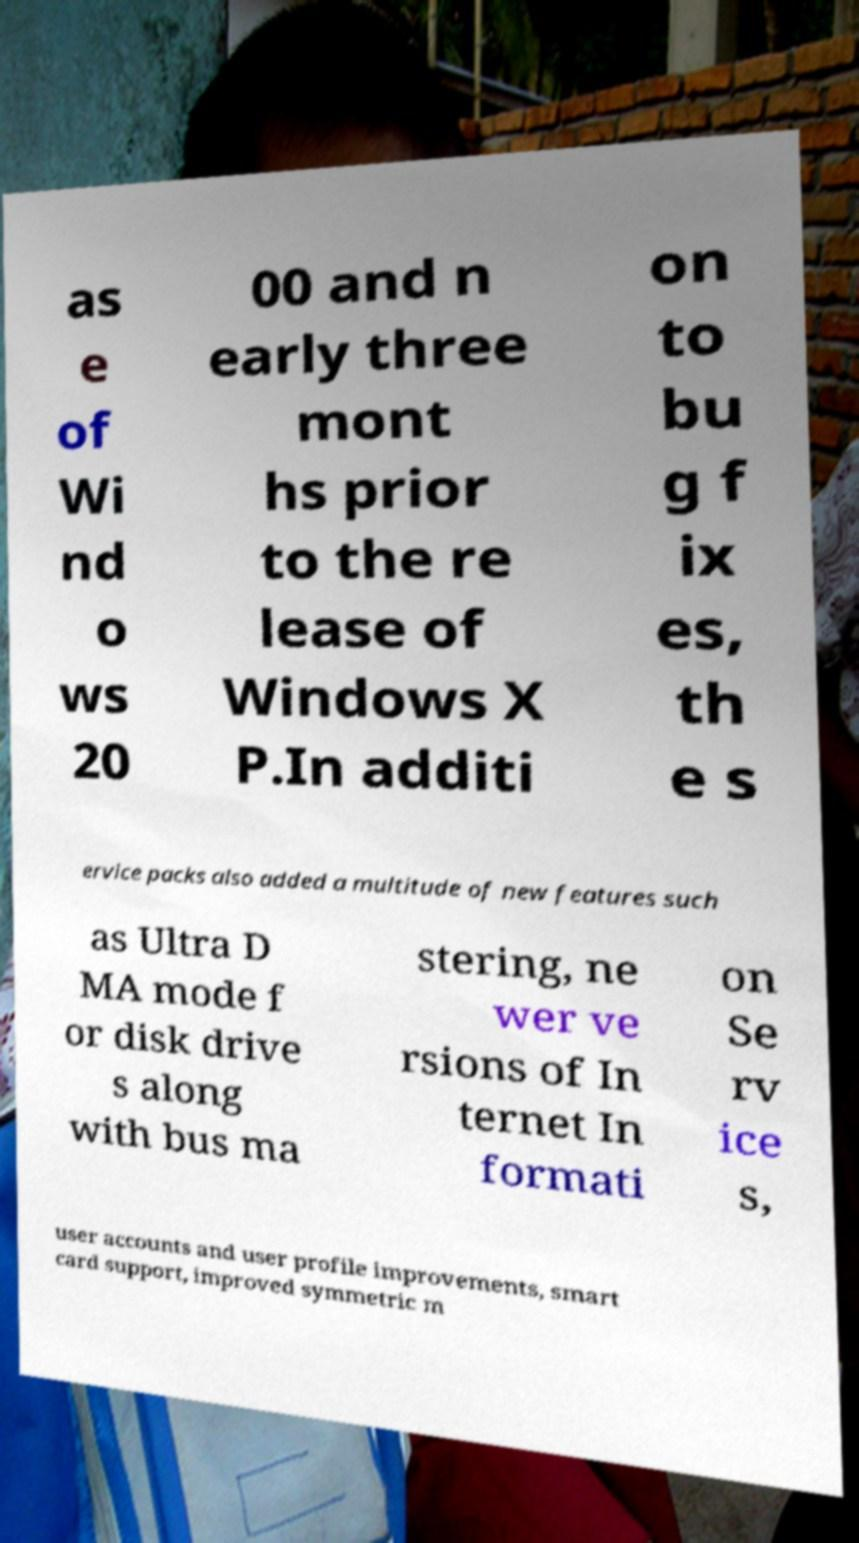Can you read and provide the text displayed in the image?This photo seems to have some interesting text. Can you extract and type it out for me? as e of Wi nd o ws 20 00 and n early three mont hs prior to the re lease of Windows X P.In additi on to bu g f ix es, th e s ervice packs also added a multitude of new features such as Ultra D MA mode f or disk drive s along with bus ma stering, ne wer ve rsions of In ternet In formati on Se rv ice s, user accounts and user profile improvements, smart card support, improved symmetric m 